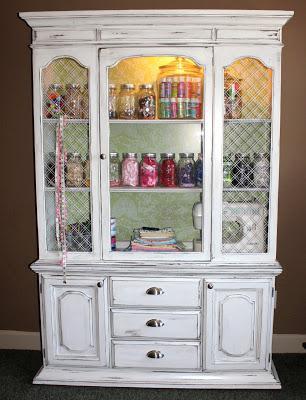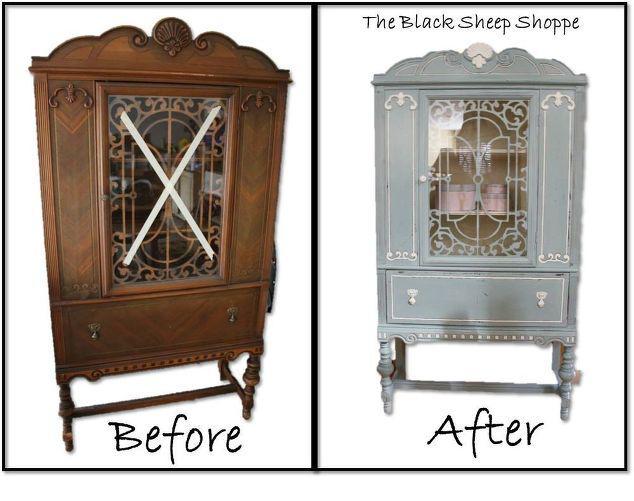The first image is the image on the left, the second image is the image on the right. Analyze the images presented: Is the assertion "There are two cabinets in one of the images." valid? Answer yes or no. Yes. 